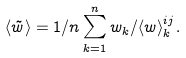Convert formula to latex. <formula><loc_0><loc_0><loc_500><loc_500>\langle \tilde { w } \rangle = 1 / n \sum _ { k = 1 } ^ { n } w _ { k } / \langle w \rangle _ { k } ^ { i j } .</formula> 